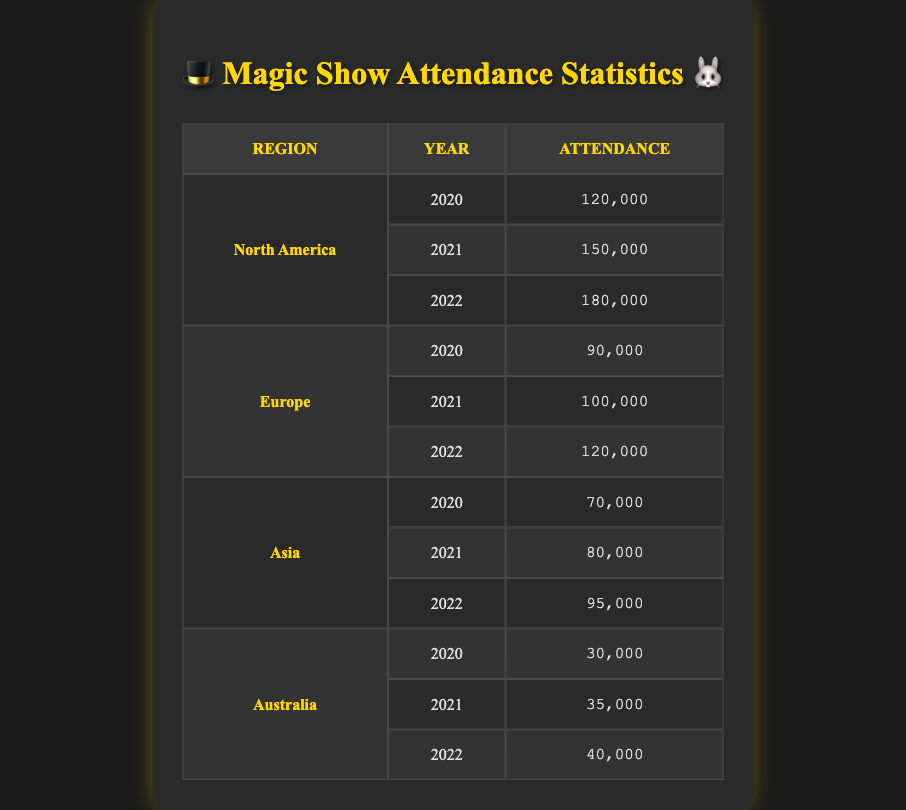What was the attendance for magic shows in Europe in 2021? The table shows the row corresponding to Europe for the year 2021, which indicates that the attendance was 100,000.
Answer: 100,000 Which region had the highest attendance in 2022? By comparing the attendance values for each region in 2022, North America has an attendance of 180,000, Europe has 120,000, Asia has 95,000, and Australia has 40,000. Therefore, North America had the highest attendance.
Answer: North America What was the total attendance for magic shows in Australia from 2020 to 2022? To find the total attendance in Australia, we sum up the attendance numbers: 30,000 (2020) + 35,000 (2021) + 40,000 (2022) = 105,000.
Answer: 105,000 Did Asia experience an increase in attendance from 2020 to 2022? By comparing the attendance numbers for Asia, we see 70,000 in 2020 and 95,000 in 2022. Since 95,000 is greater than 70,000, Asia did experience an increase.
Answer: Yes What is the average attendance for magic shows in North America over the three years? The attendance for North America over the three years is 120,000 in 2020, 150,000 in 2021, and 180,000 in 2022. To find the average, we calculate (120,000 + 150,000 + 180,000) / 3 = 450,000 / 3 = 150,000.
Answer: 150,000 Which region had the second-lowest attendance in 2020? The attendance in 2020 for each region was as follows: North America 120,000, Europe 90,000, Asia 70,000, and Australia 30,000. The second-lowest attendance, therefore, is Europe, with 90,000.
Answer: Europe Was the attendance in North America higher than in Europe in 2021? The attendance figures show that North America had 150,000 in 2021, while Europe had 100,000. Since 150,000 is greater than 100,000, North America had higher attendance.
Answer: Yes What was the percentage increase in attendance in Asia from 2020 to 2022? To find the percentage increase, we take the attendance in 2022 (95,000) and subtract the attendance in 2020 (70,000), giving us a difference of 25,000. We then divide this increase by the 2020 attendance (70,000) and multiply by 100: (25,000 / 70,000) * 100 = approximately 35.71%.
Answer: 35.71% 